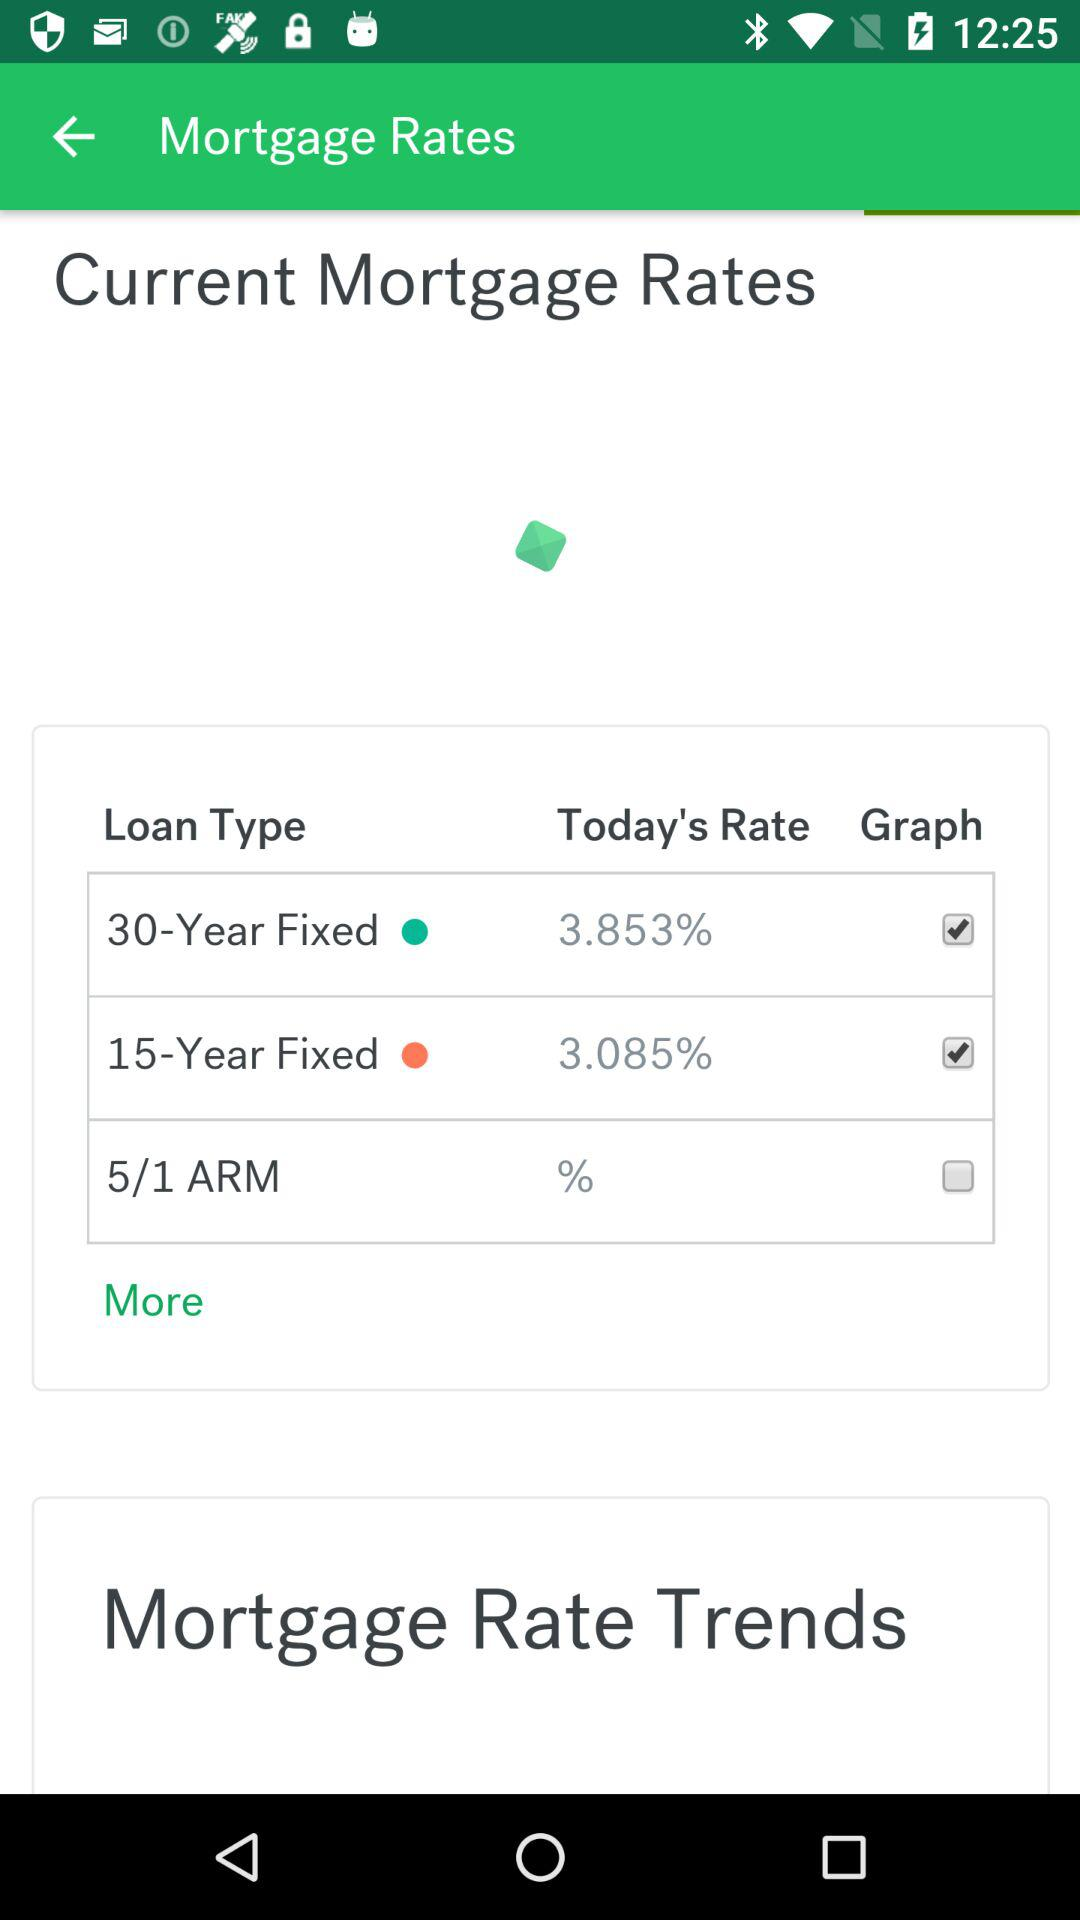What is the today's rate of "30-Year fixed" loan type? Today's rate is 3.853%. 